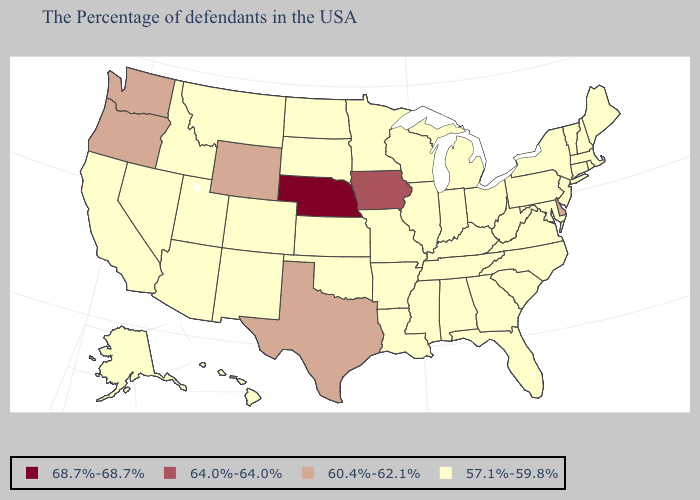What is the value of Vermont?
Quick response, please. 57.1%-59.8%. What is the value of South Dakota?
Be succinct. 57.1%-59.8%. Name the states that have a value in the range 64.0%-64.0%?
Be succinct. Iowa. Among the states that border Illinois , does Iowa have the highest value?
Be succinct. Yes. Name the states that have a value in the range 68.7%-68.7%?
Answer briefly. Nebraska. What is the lowest value in the USA?
Quick response, please. 57.1%-59.8%. Among the states that border Arkansas , does Texas have the highest value?
Give a very brief answer. Yes. Does the first symbol in the legend represent the smallest category?
Be succinct. No. Among the states that border New York , which have the highest value?
Short answer required. Massachusetts, Vermont, Connecticut, New Jersey, Pennsylvania. What is the value of Minnesota?
Answer briefly. 57.1%-59.8%. What is the lowest value in the USA?
Short answer required. 57.1%-59.8%. What is the value of South Carolina?
Short answer required. 57.1%-59.8%. Does Nebraska have the highest value in the MidWest?
Short answer required. Yes. What is the highest value in the USA?
Give a very brief answer. 68.7%-68.7%. 